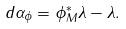Convert formula to latex. <formula><loc_0><loc_0><loc_500><loc_500>d \alpha _ { \phi } = \phi _ { M } ^ { \ast } \lambda - \lambda .</formula> 